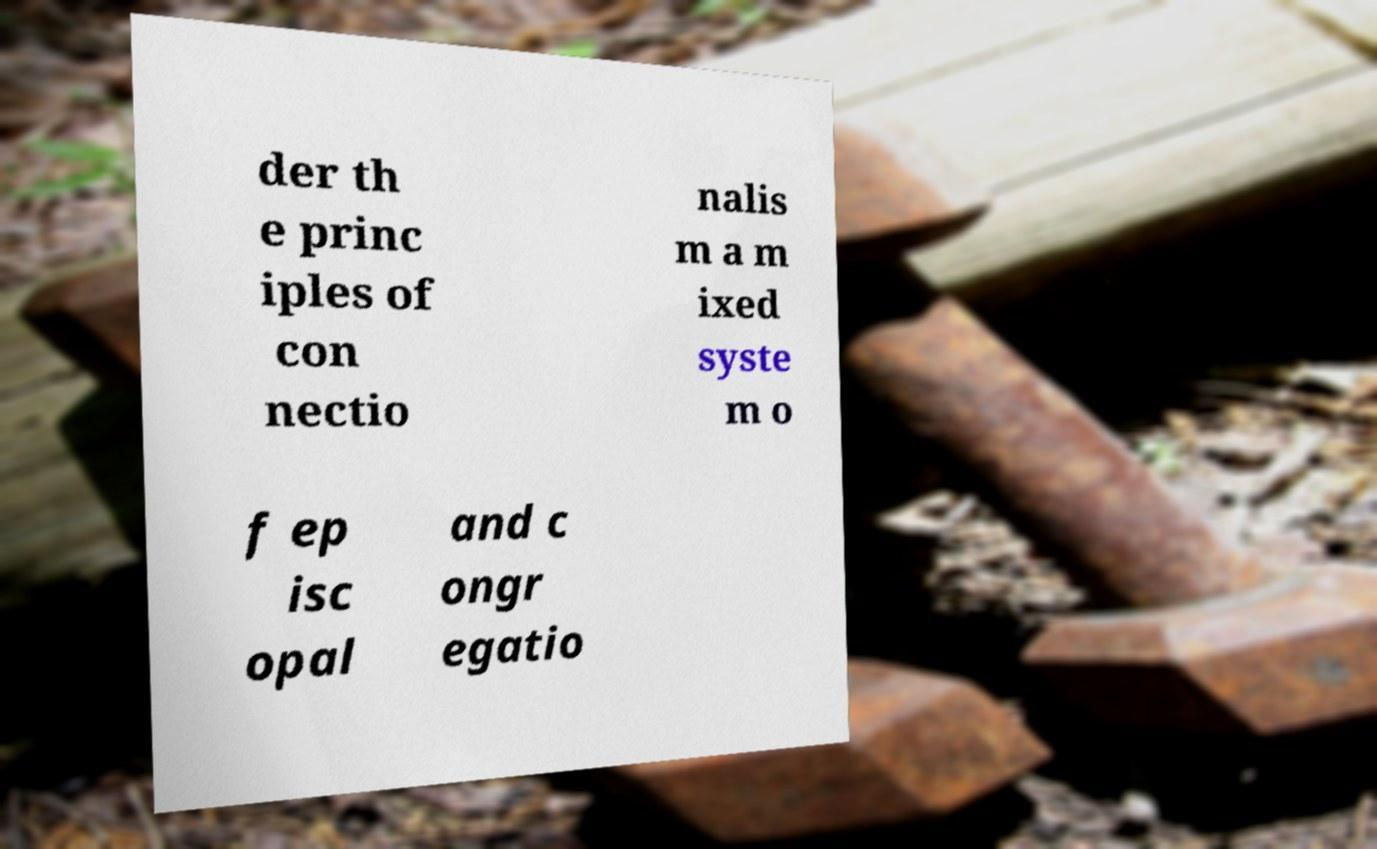I need the written content from this picture converted into text. Can you do that? der th e princ iples of con nectio nalis m a m ixed syste m o f ep isc opal and c ongr egatio 